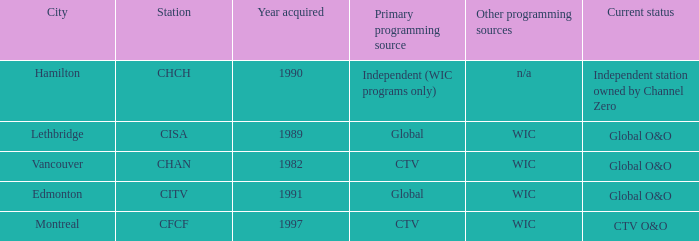How any were gained as the chan 1.0. 